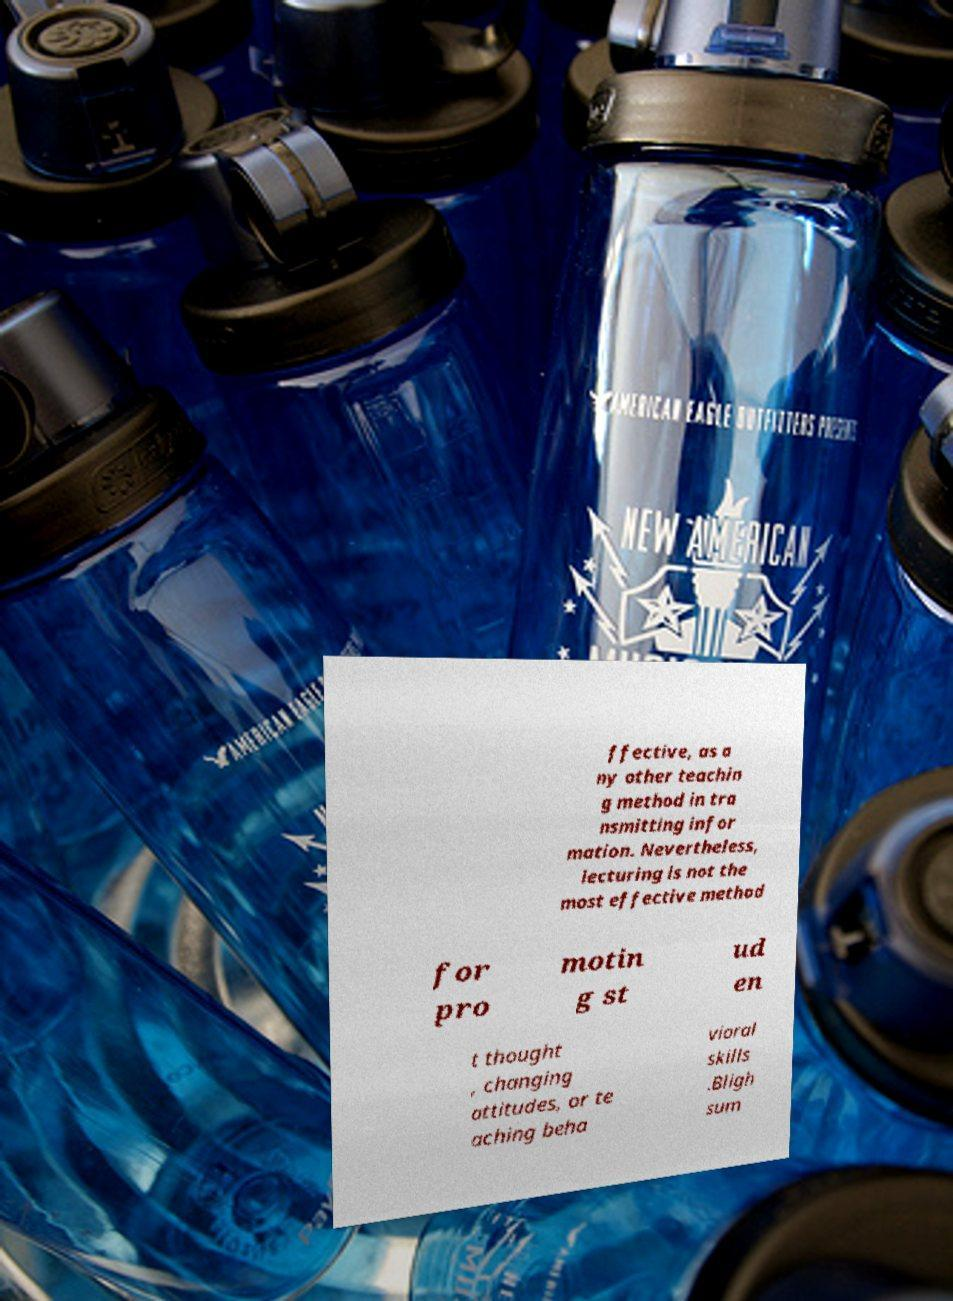Could you assist in decoding the text presented in this image and type it out clearly? ffective, as a ny other teachin g method in tra nsmitting infor mation. Nevertheless, lecturing is not the most effective method for pro motin g st ud en t thought , changing attitudes, or te aching beha vioral skills .Bligh sum 